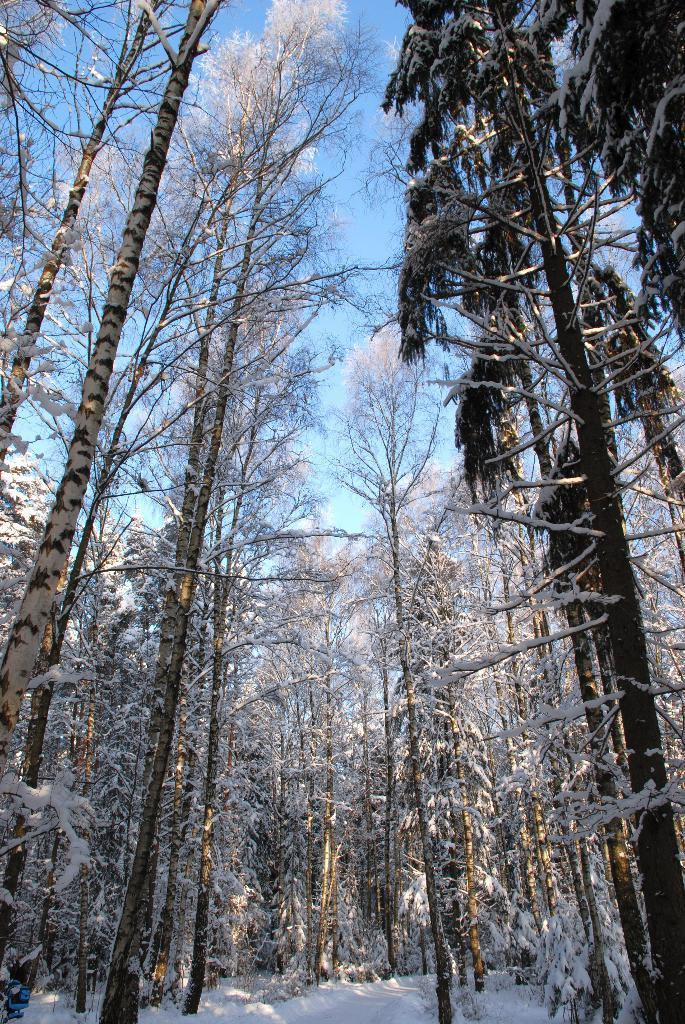What type of vegetation is present in the image? There are trees in the image. What is the condition of the ground in the image? The trees are on a snow surface, so the ground is covered in snow. Can you describe the sky in the image? The sky is visible in the background of the image. Is there any snow on the trees in the image? Yes, there is snow on the trees in the image. Where is the man sleeping in the image? There is no man present in the image; it features trees on a snow surface with snow on them. 